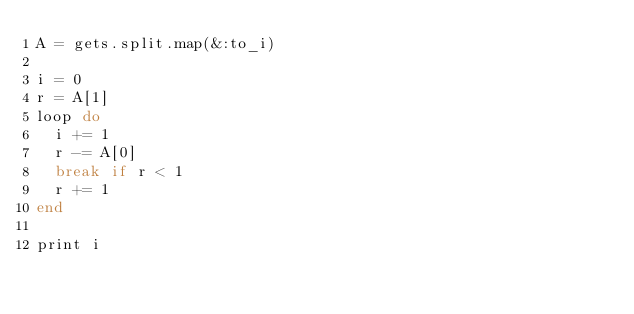Convert code to text. <code><loc_0><loc_0><loc_500><loc_500><_Ruby_>A = gets.split.map(&:to_i)

i = 0
r = A[1]
loop do
  i += 1
  r -= A[0]
  break if r < 1
  r += 1
end
 
print i</code> 